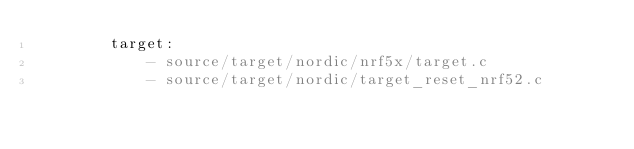<code> <loc_0><loc_0><loc_500><loc_500><_YAML_>        target:
            - source/target/nordic/nrf5x/target.c
            - source/target/nordic/target_reset_nrf52.c
</code> 